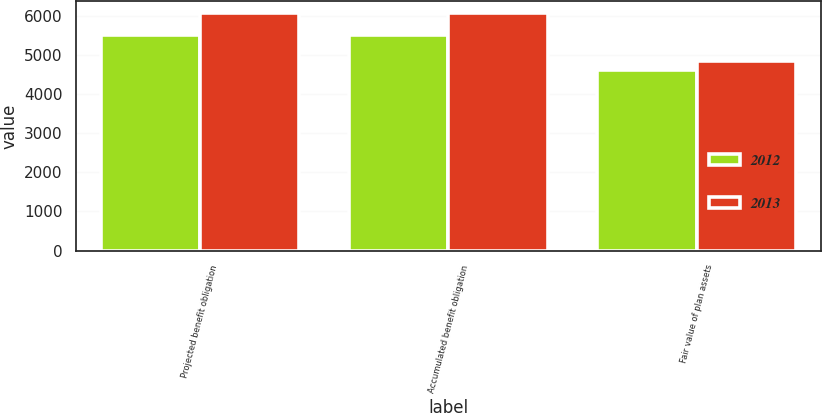Convert chart to OTSL. <chart><loc_0><loc_0><loc_500><loc_500><stacked_bar_chart><ecel><fcel>Projected benefit obligation<fcel>Accumulated benefit obligation<fcel>Fair value of plan assets<nl><fcel>2012<fcel>5516<fcel>5515<fcel>4630<nl><fcel>2013<fcel>6080<fcel>6079<fcel>4850<nl></chart> 